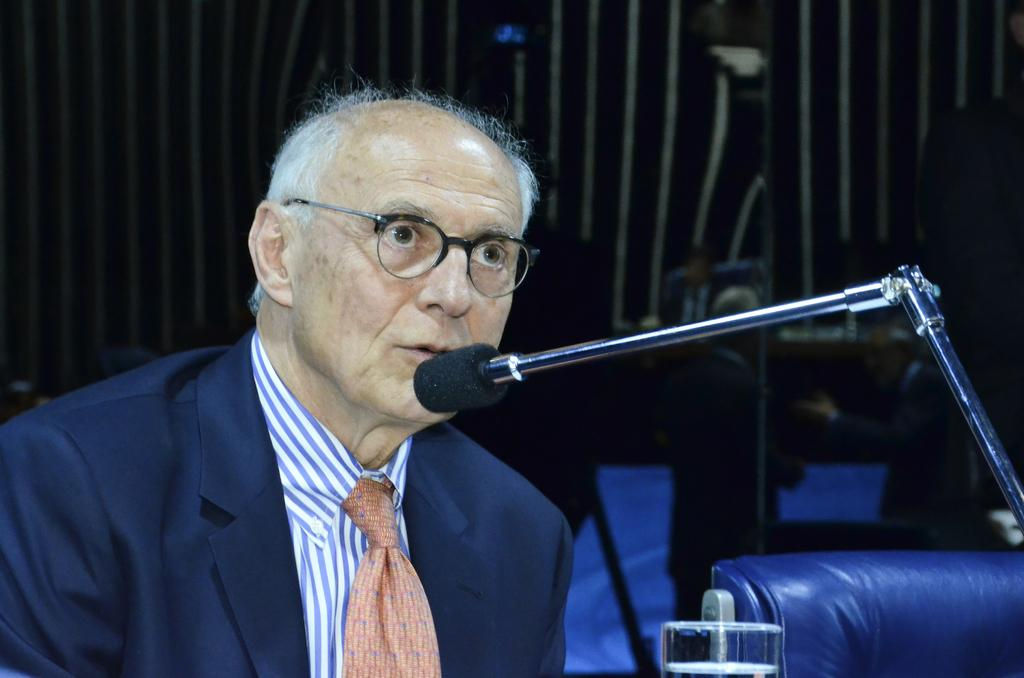What is the person in the image doing? The person is talking in front of a microphone. Can you describe any objects related to the person's activity? There is a glass in the image. Is there any furniture present in the image? Yes, there is a chair in the image. How many houses can be seen in the image? There are no houses visible in the image. What type of milk is being poured into the glass in the image? There is no milk present in the image; it only shows a glass. Can you tell me if the person in the image has a toothache? There is no information about the person's dental health in the image. 